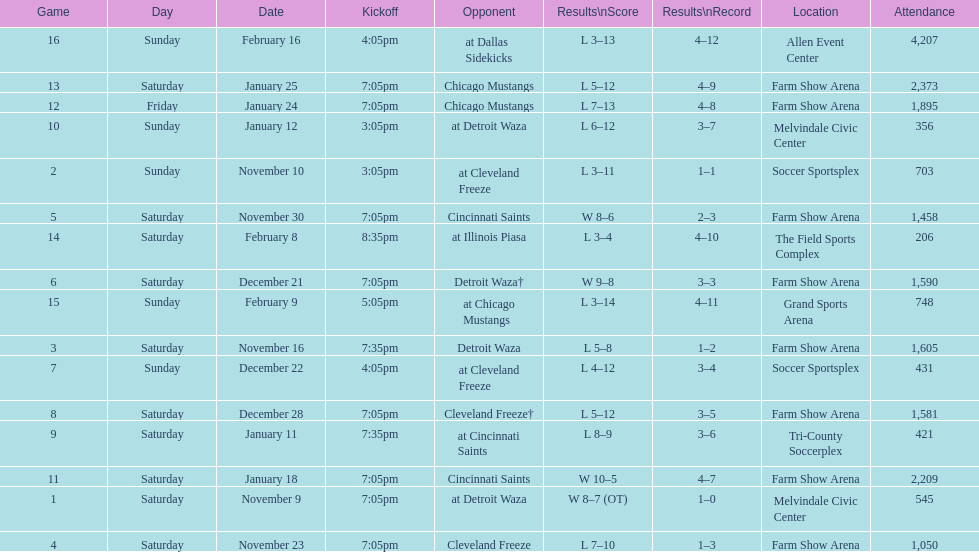Which opponent is listed first in the table? Detroit Waza. 